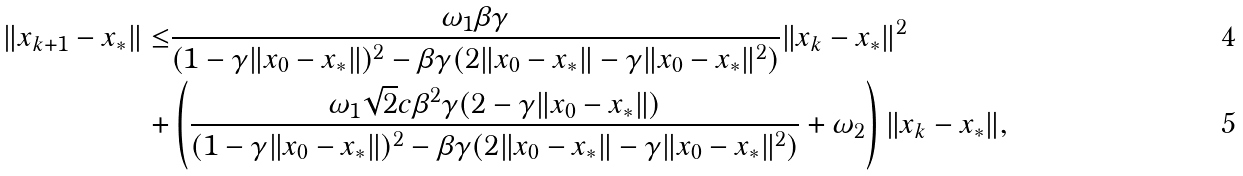Convert formula to latex. <formula><loc_0><loc_0><loc_500><loc_500>\| x _ { k + 1 } - x _ { * } \| \leq & \frac { \omega _ { 1 } \beta \gamma } { ( 1 - \gamma \| x _ { 0 } - x _ { * } \| ) ^ { 2 } - \beta \gamma ( 2 \| x _ { 0 } - x _ { * } \| - \gamma \| x _ { 0 } - x _ { * } \| ^ { 2 } ) } \| x _ { k } - x _ { * } \| ^ { 2 } \\ + & \left ( \frac { \omega _ { 1 } \sqrt { 2 } c \beta ^ { 2 } \gamma ( 2 - \gamma \| x _ { 0 } - x _ { * } \| ) } { ( 1 - \gamma \| x _ { 0 } - x _ { * } \| ) ^ { 2 } - \beta \gamma ( 2 \| x _ { 0 } - x _ { * } \| - \gamma \| x _ { 0 } - x _ { * } \| ^ { 2 } ) } + \omega _ { 2 } \right ) \| x _ { k } - x _ { * } \| ,</formula> 